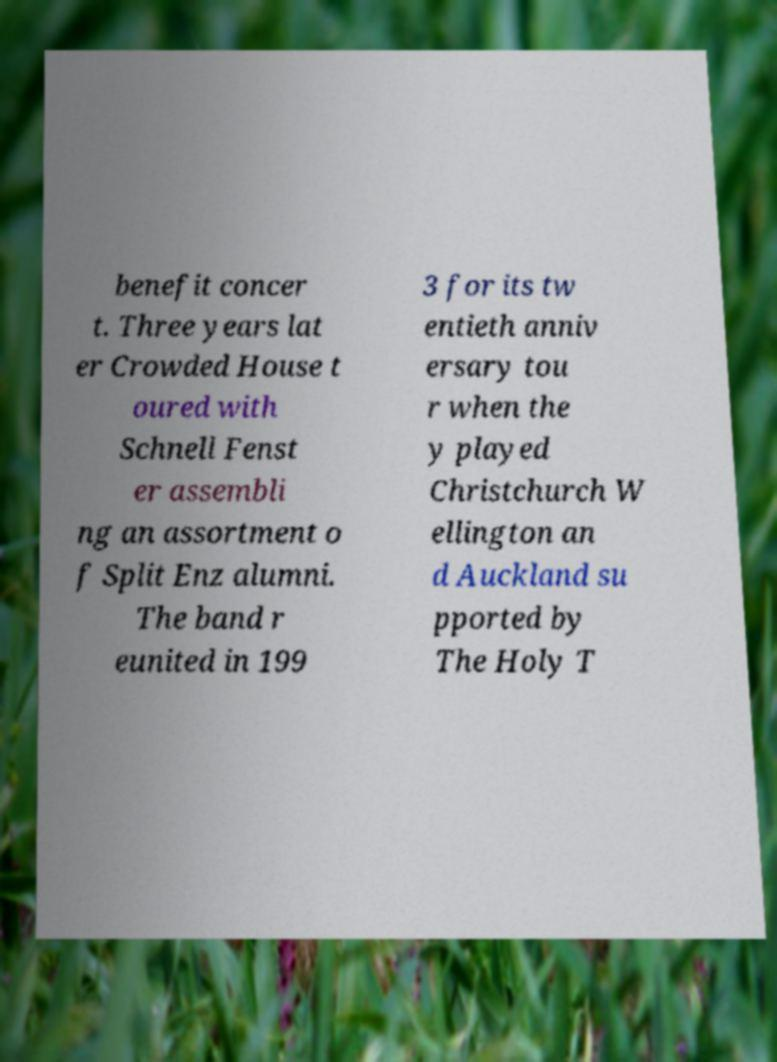For documentation purposes, I need the text within this image transcribed. Could you provide that? benefit concer t. Three years lat er Crowded House t oured with Schnell Fenst er assembli ng an assortment o f Split Enz alumni. The band r eunited in 199 3 for its tw entieth anniv ersary tou r when the y played Christchurch W ellington an d Auckland su pported by The Holy T 